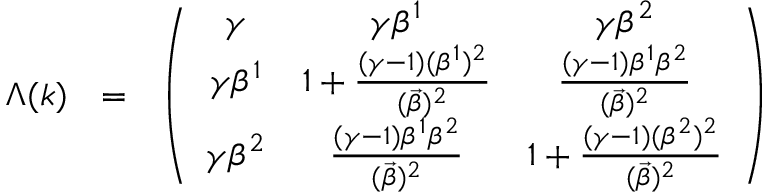Convert formula to latex. <formula><loc_0><loc_0><loc_500><loc_500>\Lambda ( k ) = \left ( \begin{array} { c c c } { \gamma } & { { { \gamma } { \beta } ^ { 1 } } } & { { { \gamma } { \beta } ^ { 2 } } } \\ { { { \gamma } { \beta } ^ { 1 } } } & { { 1 + \frac { ( { \gamma } - 1 ) ( { \beta } ^ { 1 } ) ^ { 2 } } { ( \vec { \beta } ) ^ { 2 } } } } & { { \frac { ( { \gamma } - 1 ) { \beta } ^ { 1 } { \beta } ^ { 2 } } { ( \vec { \beta } ) ^ { 2 } } } } \\ { { { \gamma } { \beta } ^ { 2 } } } & { { \frac { ( { \gamma } - 1 ) { \beta } ^ { 1 } { \beta } ^ { 2 } } { ( \vec { \beta } ) ^ { 2 } } } } & { { 1 + \frac { ( { \gamma } - 1 ) ( { \beta } ^ { 2 } ) ^ { 2 } } { ( \vec { \beta } ) ^ { 2 } } } } \end{array} \right )</formula> 